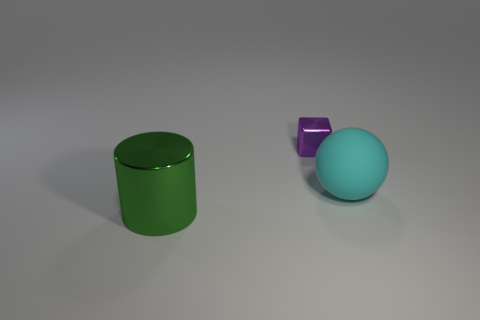Are there any other things that have the same material as the cyan ball?
Keep it short and to the point. No. Is the size of the metal object that is on the right side of the green metal thing the same as the shiny object that is in front of the cyan rubber object?
Keep it short and to the point. No. How big is the metallic object in front of the big cyan rubber thing?
Your answer should be compact. Large. What is the size of the object that is made of the same material as the block?
Keep it short and to the point. Large. Are there any other things that are the same size as the purple metal object?
Provide a succinct answer. No. What material is the object that is on the right side of the purple metallic object?
Give a very brief answer. Rubber. There is a metal object that is behind the big thing left of the tiny purple shiny cube; what number of small purple objects are on the left side of it?
Make the answer very short. 0. Are there any other things that have the same shape as the large green metal thing?
Provide a succinct answer. No. How many cylinders are either large cyan objects or large green metal objects?
Your answer should be compact. 1. The tiny purple shiny object is what shape?
Provide a succinct answer. Cube. 